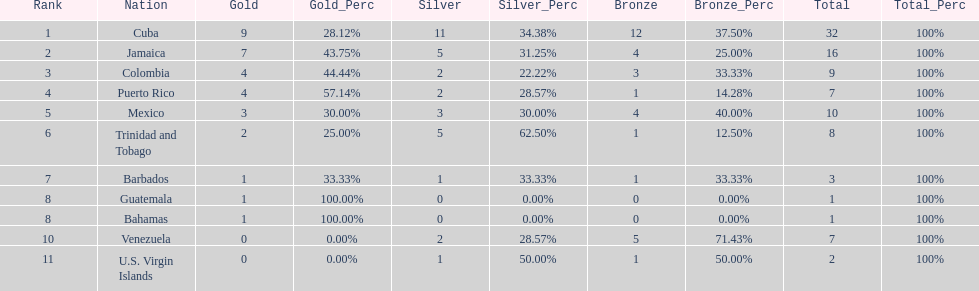Which nations played in the games? Cuba, Jamaica, Colombia, Puerto Rico, Mexico, Trinidad and Tobago, Barbados, Guatemala, Bahamas, Venezuela, U.S. Virgin Islands. How many silver medals did they win? 11, 5, 2, 2, 3, 5, 1, 0, 0, 2, 1. Which team won the most silver? Cuba. 